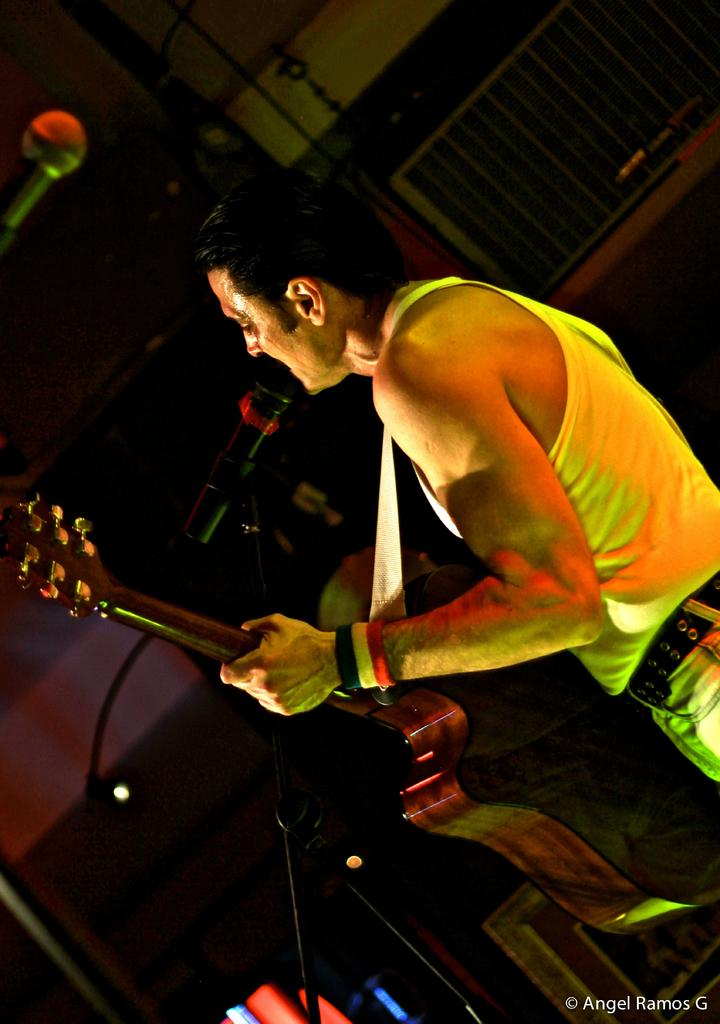What is the man in the image doing? The man is playing a guitar in the image. What object is present that is commonly used for amplifying sound? There is a microphone in the image. What type of stew is being prepared on the stage in the image? There is no stew or stage present in the image; it features a man playing a guitar and a microphone. How does the man's memory affect his performance in the image? The image does not provide any information about the man's memory, so it cannot be determined how it affects his performance. 